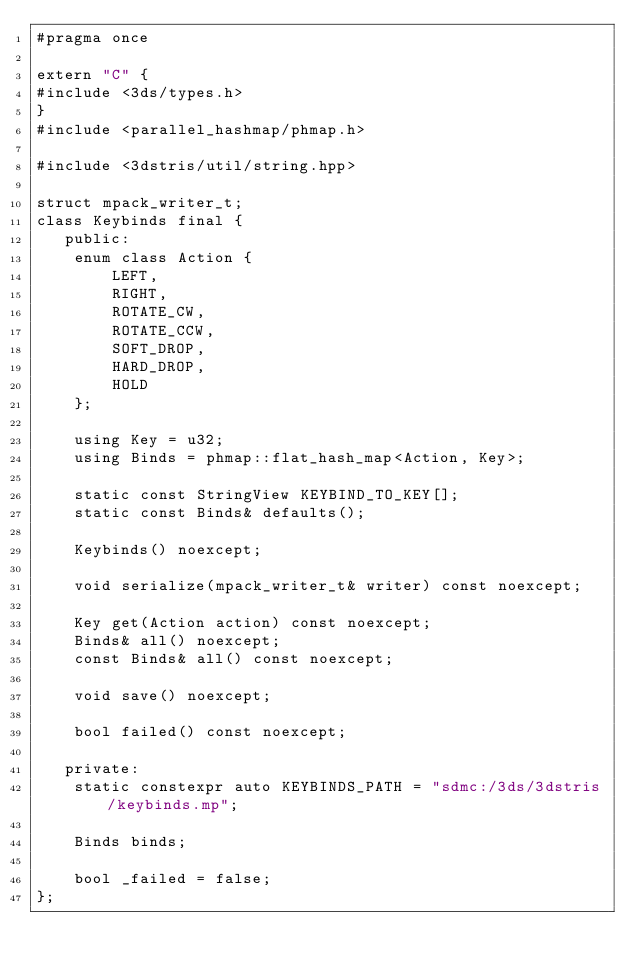Convert code to text. <code><loc_0><loc_0><loc_500><loc_500><_C++_>#pragma once

extern "C" {
#include <3ds/types.h>
}
#include <parallel_hashmap/phmap.h>

#include <3dstris/util/string.hpp>

struct mpack_writer_t;
class Keybinds final {
   public:
	enum class Action {
		LEFT,
		RIGHT,
		ROTATE_CW,
		ROTATE_CCW,
		SOFT_DROP,
		HARD_DROP,
		HOLD
	};

	using Key = u32;
	using Binds = phmap::flat_hash_map<Action, Key>;

	static const StringView KEYBIND_TO_KEY[];
	static const Binds& defaults();

	Keybinds() noexcept;

	void serialize(mpack_writer_t& writer) const noexcept;

	Key get(Action action) const noexcept;
	Binds& all() noexcept;
	const Binds& all() const noexcept;

	void save() noexcept;

	bool failed() const noexcept;

   private:
	static constexpr auto KEYBINDS_PATH = "sdmc:/3ds/3dstris/keybinds.mp";

	Binds binds;

	bool _failed = false;
};
</code> 